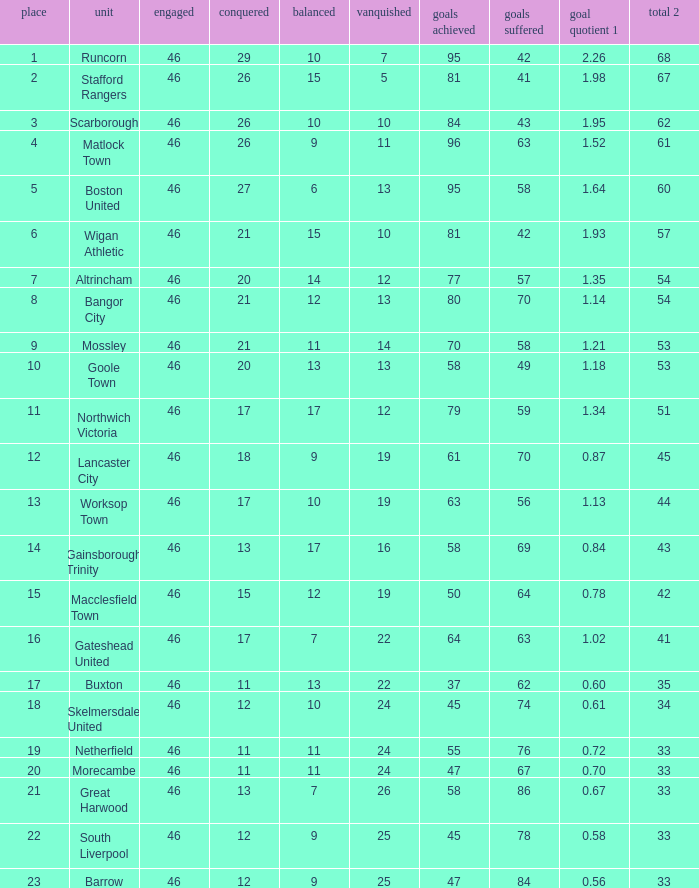What is the highest position of the Bangor City team? 8.0. 